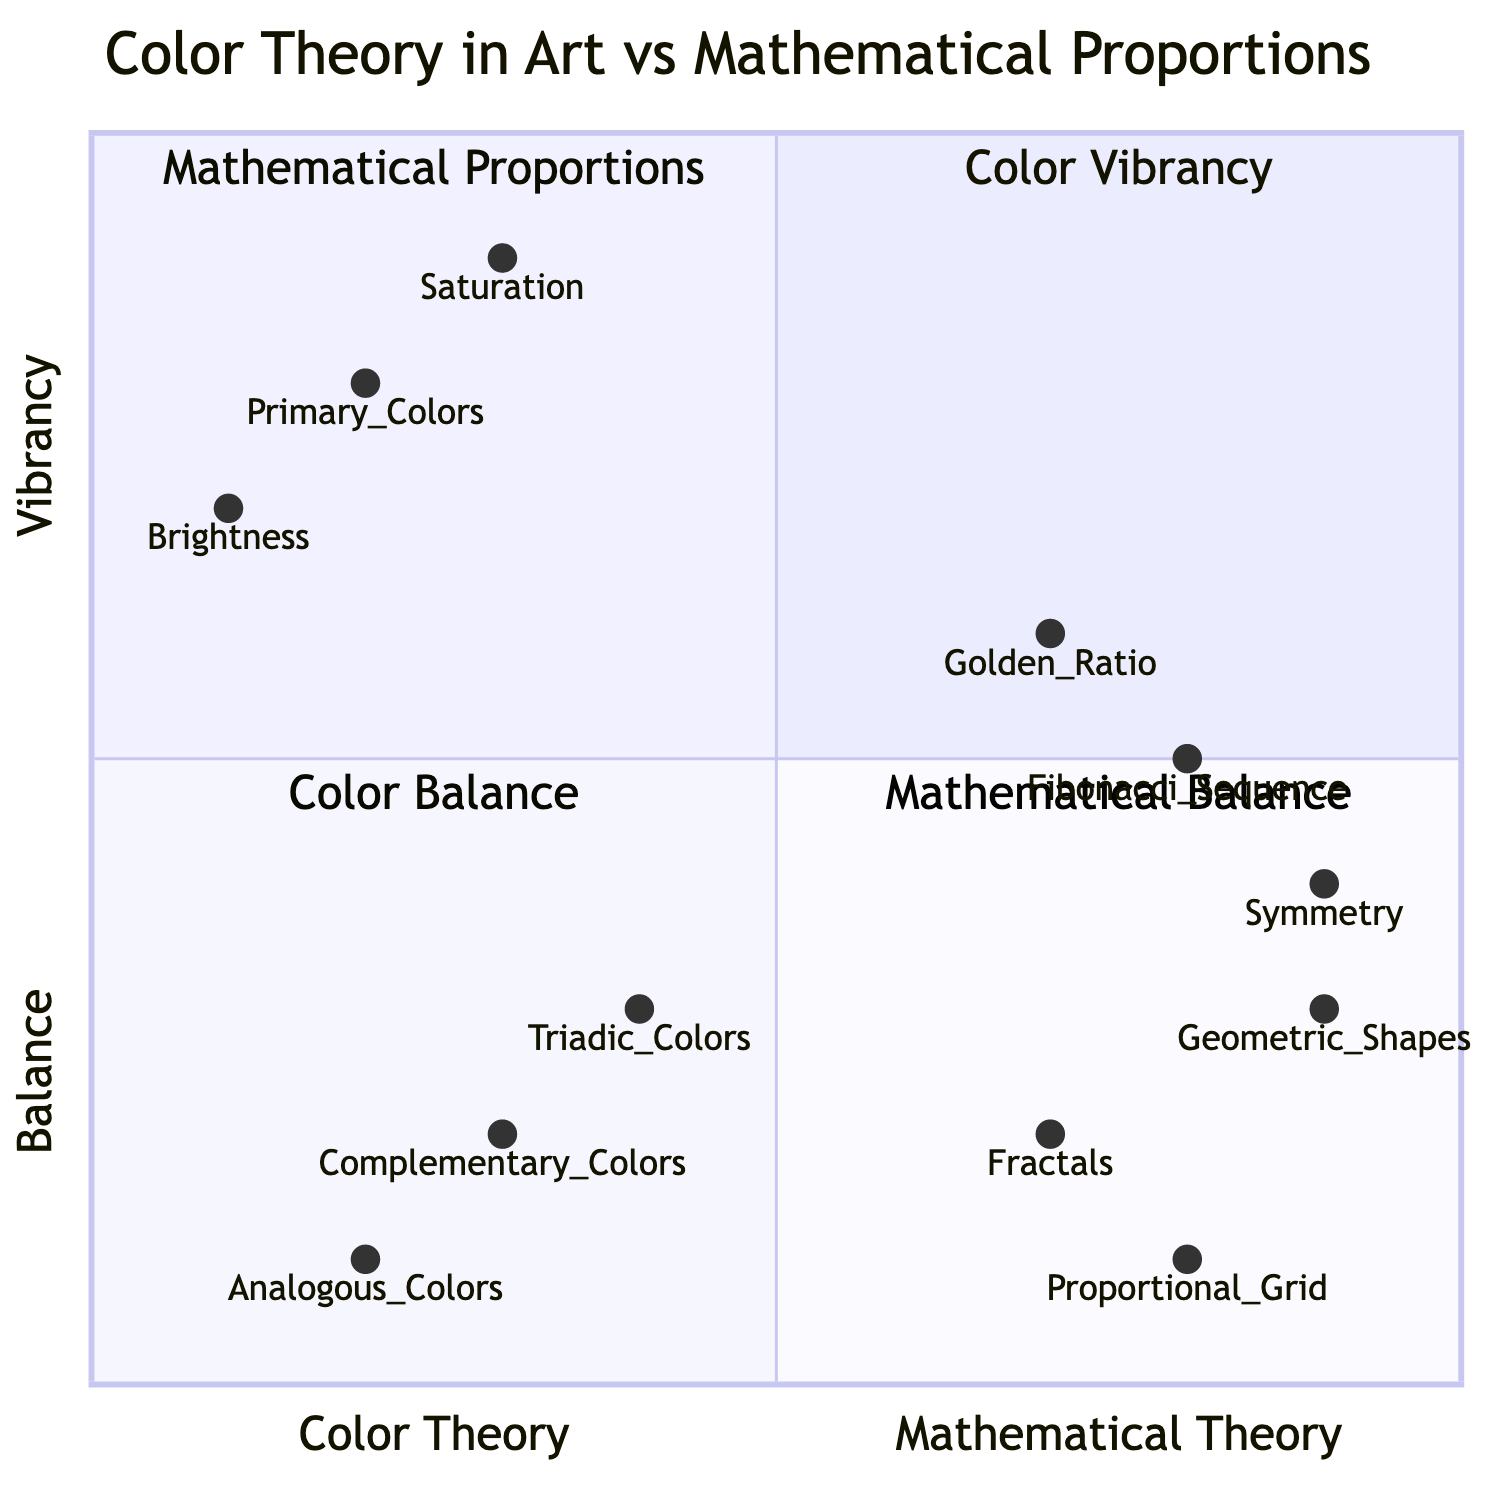What are the three elements in the "Color Vibrancy" quadrant? The "Color Vibrancy" quadrant includes three elements: Primary Colors, Saturation, and Brightness.
Answer: Primary Colors, Saturation, Brightness Which element is located in the "Mathematical Proportions" quadrant? The "Mathematical Proportions" quadrant includes three elements: Golden Ratio, Fibonacci Sequence, and Symmetry. One of them is the Golden Ratio.
Answer: Golden Ratio What color theory element has the coordinates [0.3, 0.2]? The coordinates [0.3, 0.2] correspond to Complementary Colors, located in the "Color Balance" quadrant.
Answer: Complementary Colors How many elements are in the "Mathematical Balance" quadrant? The "Mathematical Balance" quadrant consists of three elements: Fractals, Proportional Grid, and Geometric Shapes. Therefore, the total number of elements is three.
Answer: 3 Which mathematical proportion element is closest to the "Color Balance" quadrant? To identify the closest element, we look at their coordinates. The Element with coordinates [0.4, 0.3], Triadic Colors, is in the "Color Balance" quadrant, which is closer when compared to any element from the "Mathematical Proportions" quadrant.
Answer: Triadic Colors Which has a higher vibrancy value, Saturation or Brightness? Saturation has a value of 0.9, while Brightness has a value of 0.7. Thus, comparing these values indicates that Saturation has a higher vibrancy value.
Answer: Saturation Identify the quadrant with the "Fibonacci Sequence" element. The "Fibonacci Sequence" element is found in the "Mathematical Proportions" quadrant within the quadrant chart.
Answer: Mathematical Proportions Which element is located at the farthest right in the quadrants? The element with the highest x-coordinate (closest to the right part of the diagram) is Geometric Shapes, with coordinates [0.9, 0.3], therefore making it the farthest right.
Answer: Geometric Shapes 